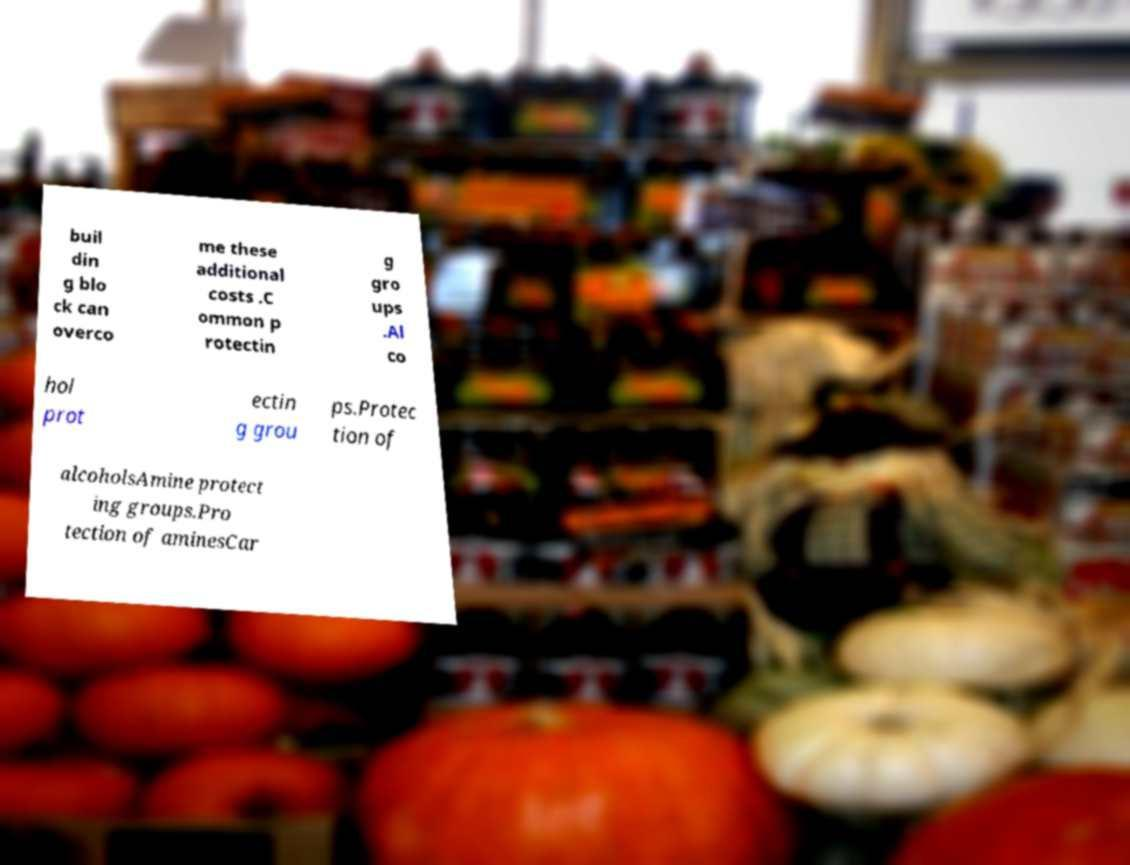Please read and relay the text visible in this image. What does it say? buil din g blo ck can overco me these additional costs .C ommon p rotectin g gro ups .Al co hol prot ectin g grou ps.Protec tion of alcoholsAmine protect ing groups.Pro tection of aminesCar 